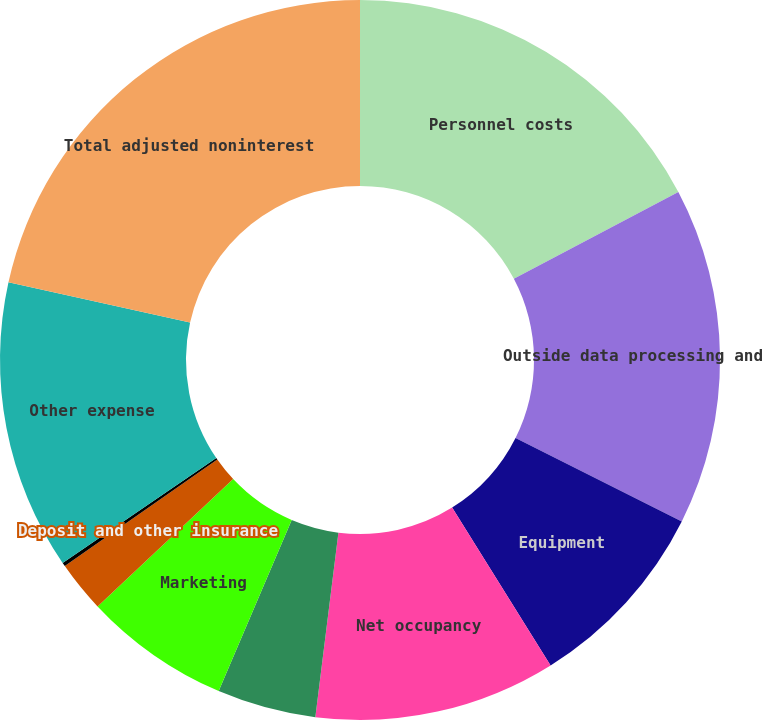Convert chart to OTSL. <chart><loc_0><loc_0><loc_500><loc_500><pie_chart><fcel>Personnel costs<fcel>Outside data processing and<fcel>Equipment<fcel>Net occupancy<fcel>Professional services<fcel>Marketing<fcel>Deposit and other insurance<fcel>Amortization of intangibles<fcel>Other expense<fcel>Total adjusted noninterest<nl><fcel>17.27%<fcel>15.13%<fcel>8.72%<fcel>10.86%<fcel>4.44%<fcel>6.58%<fcel>2.3%<fcel>0.17%<fcel>12.99%<fcel>21.54%<nl></chart> 